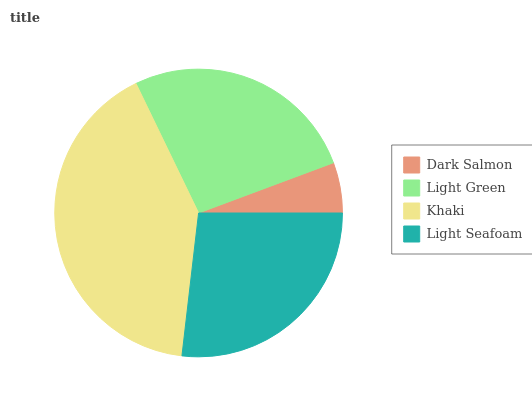Is Dark Salmon the minimum?
Answer yes or no. Yes. Is Khaki the maximum?
Answer yes or no. Yes. Is Light Green the minimum?
Answer yes or no. No. Is Light Green the maximum?
Answer yes or no. No. Is Light Green greater than Dark Salmon?
Answer yes or no. Yes. Is Dark Salmon less than Light Green?
Answer yes or no. Yes. Is Dark Salmon greater than Light Green?
Answer yes or no. No. Is Light Green less than Dark Salmon?
Answer yes or no. No. Is Light Seafoam the high median?
Answer yes or no. Yes. Is Light Green the low median?
Answer yes or no. Yes. Is Light Green the high median?
Answer yes or no. No. Is Dark Salmon the low median?
Answer yes or no. No. 